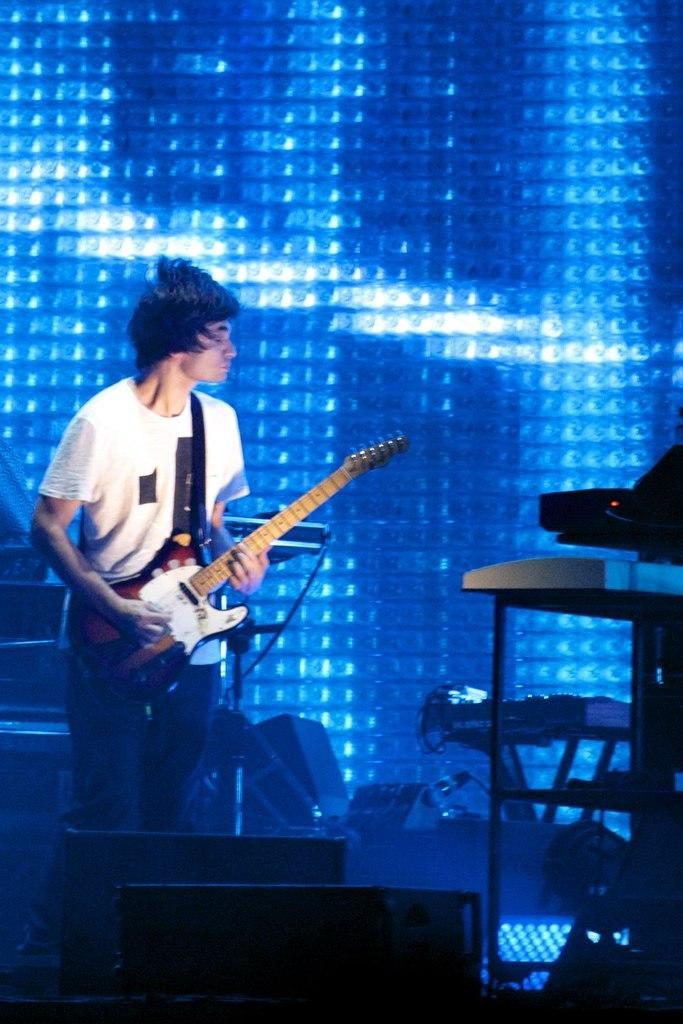What is the main subject of the image? The main subject of the image is a man. What is the man wearing? The man is wearing clothes. What is the man holding in his hand? The man is holding a guitar in his hand. What else can be seen in the image besides the man? There is a cable wire, musical instruments, and a background light in the image. What type of crime is being committed in the image? There is no crime being committed in the image; it features a man holding a guitar and other musical instruments. What is the cannon used for in the image? There is no cannon present in the image. 